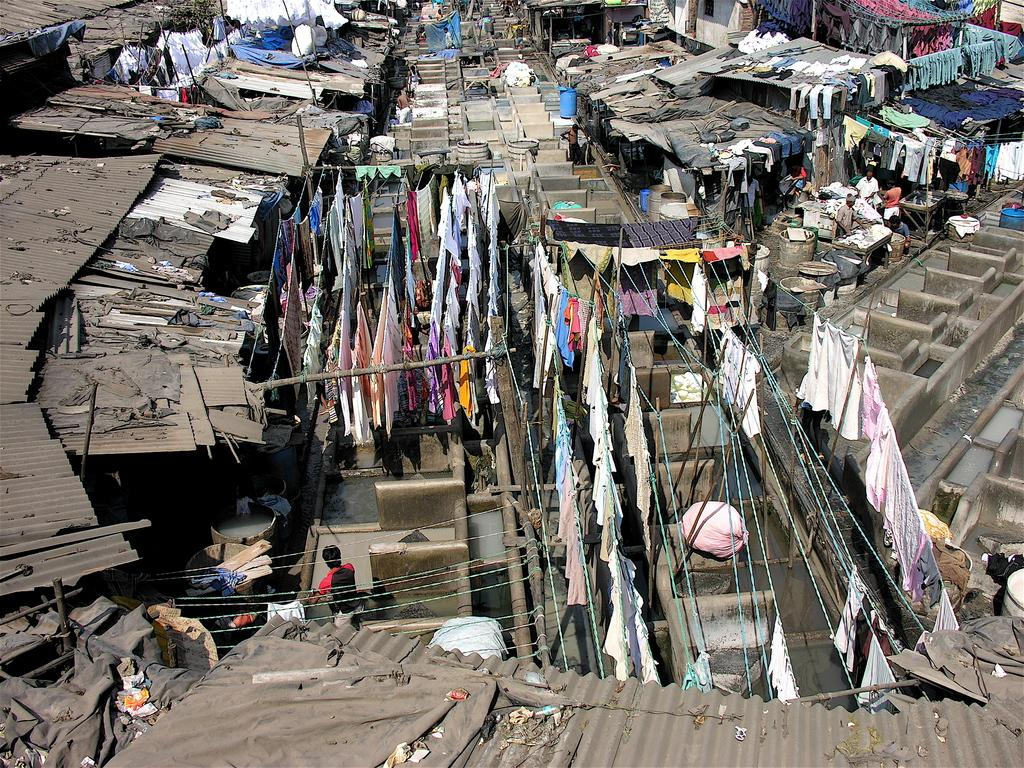What perspective is the image taken from? The image is taken from a top view. What can be seen hanging on the ropes in the image? There are clothes on ropes in the image. What type of structures are visible in the image? There are roofs visible in the image. What color is the crayon used to draw on the roofs in the image? There is no crayon or drawing present on the roofs in the image. What type of substance is dripping from the clothes on the ropes in the image? There is no substance dripping from the clothes on the ropes in the image. 